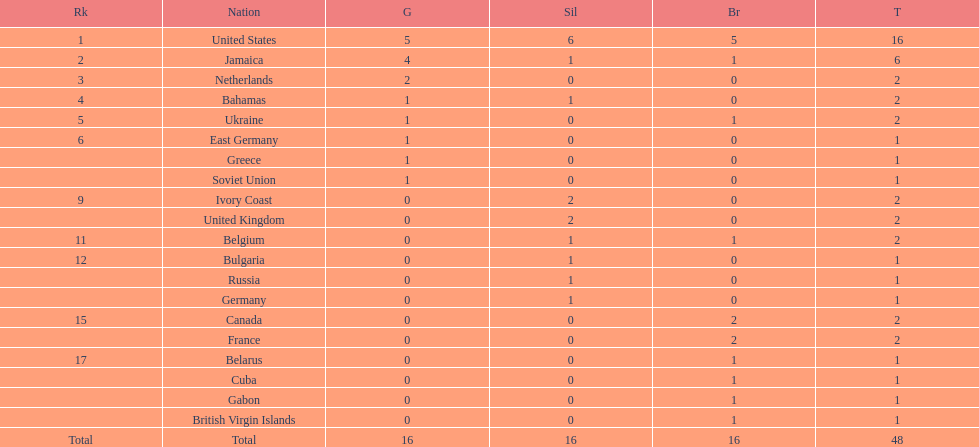After the united states, what country won the most gold medals. Jamaica. 